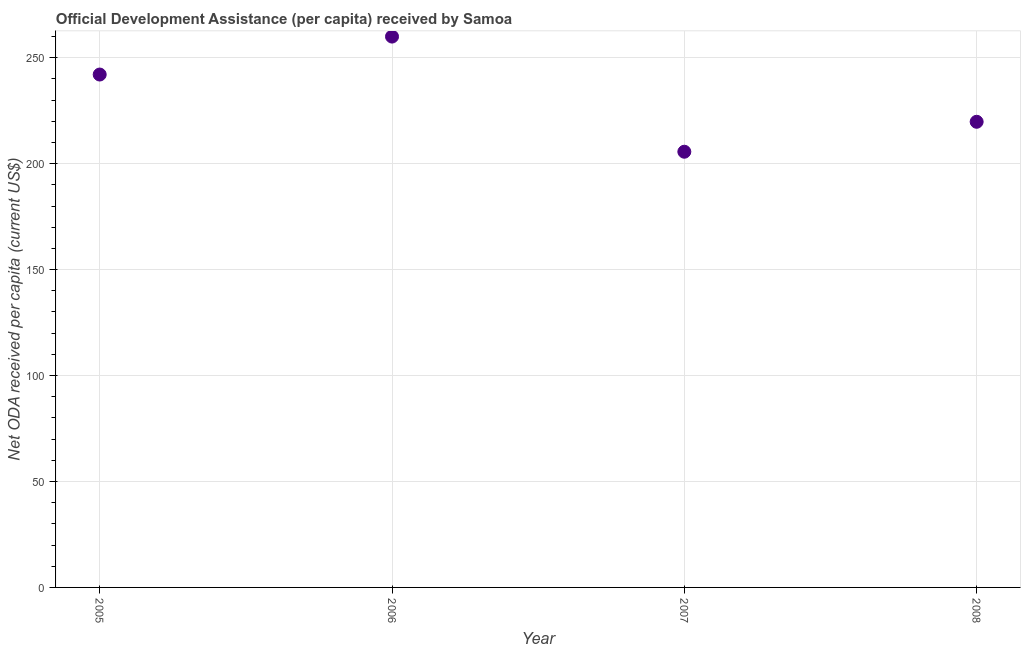What is the net oda received per capita in 2007?
Offer a terse response. 205.61. Across all years, what is the maximum net oda received per capita?
Provide a succinct answer. 259.95. Across all years, what is the minimum net oda received per capita?
Your answer should be very brief. 205.61. In which year was the net oda received per capita maximum?
Provide a succinct answer. 2006. In which year was the net oda received per capita minimum?
Your response must be concise. 2007. What is the sum of the net oda received per capita?
Your answer should be very brief. 927.35. What is the difference between the net oda received per capita in 2006 and 2008?
Offer a very short reply. 40.21. What is the average net oda received per capita per year?
Ensure brevity in your answer.  231.84. What is the median net oda received per capita?
Your answer should be compact. 230.89. Do a majority of the years between 2007 and 2008 (inclusive) have net oda received per capita greater than 200 US$?
Offer a very short reply. Yes. What is the ratio of the net oda received per capita in 2005 to that in 2006?
Make the answer very short. 0.93. Is the net oda received per capita in 2005 less than that in 2008?
Provide a short and direct response. No. What is the difference between the highest and the second highest net oda received per capita?
Your answer should be very brief. 17.91. Is the sum of the net oda received per capita in 2006 and 2007 greater than the maximum net oda received per capita across all years?
Ensure brevity in your answer.  Yes. What is the difference between the highest and the lowest net oda received per capita?
Your answer should be compact. 54.34. In how many years, is the net oda received per capita greater than the average net oda received per capita taken over all years?
Your answer should be compact. 2. Does the net oda received per capita monotonically increase over the years?
Offer a very short reply. No. What is the title of the graph?
Make the answer very short. Official Development Assistance (per capita) received by Samoa. What is the label or title of the Y-axis?
Provide a succinct answer. Net ODA received per capita (current US$). What is the Net ODA received per capita (current US$) in 2005?
Offer a terse response. 242.04. What is the Net ODA received per capita (current US$) in 2006?
Offer a terse response. 259.95. What is the Net ODA received per capita (current US$) in 2007?
Your answer should be compact. 205.61. What is the Net ODA received per capita (current US$) in 2008?
Give a very brief answer. 219.74. What is the difference between the Net ODA received per capita (current US$) in 2005 and 2006?
Provide a succinct answer. -17.91. What is the difference between the Net ODA received per capita (current US$) in 2005 and 2007?
Provide a succinct answer. 36.43. What is the difference between the Net ODA received per capita (current US$) in 2005 and 2008?
Give a very brief answer. 22.3. What is the difference between the Net ODA received per capita (current US$) in 2006 and 2007?
Ensure brevity in your answer.  54.34. What is the difference between the Net ODA received per capita (current US$) in 2006 and 2008?
Keep it short and to the point. 40.21. What is the difference between the Net ODA received per capita (current US$) in 2007 and 2008?
Offer a very short reply. -14.13. What is the ratio of the Net ODA received per capita (current US$) in 2005 to that in 2007?
Offer a very short reply. 1.18. What is the ratio of the Net ODA received per capita (current US$) in 2005 to that in 2008?
Offer a terse response. 1.1. What is the ratio of the Net ODA received per capita (current US$) in 2006 to that in 2007?
Your answer should be compact. 1.26. What is the ratio of the Net ODA received per capita (current US$) in 2006 to that in 2008?
Give a very brief answer. 1.18. What is the ratio of the Net ODA received per capita (current US$) in 2007 to that in 2008?
Offer a very short reply. 0.94. 